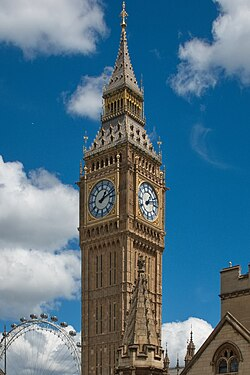Can you provide a poetic description of the clock tower? Beneath the azure dome of sky, a sentinel stands tall, Etched in time, where shadows dance and sunbeams fall. Big Ben, with its iron heart and chimes of yore, Rings through centuries, a mighty, timeless roar. The tower's grandeur reaches for the clouds on high, A symphony in stone, beneath the London sky. Each clock face whispers tales of epochs long ago, A silent witness to the city's ebb and flow. In brick and spire, it guards the twilight's kiss, A symbol of endurance in a world of fleeting bliss. Here, history and future in a spiral embrace, Big Ben, eternal, in its sacred space. 